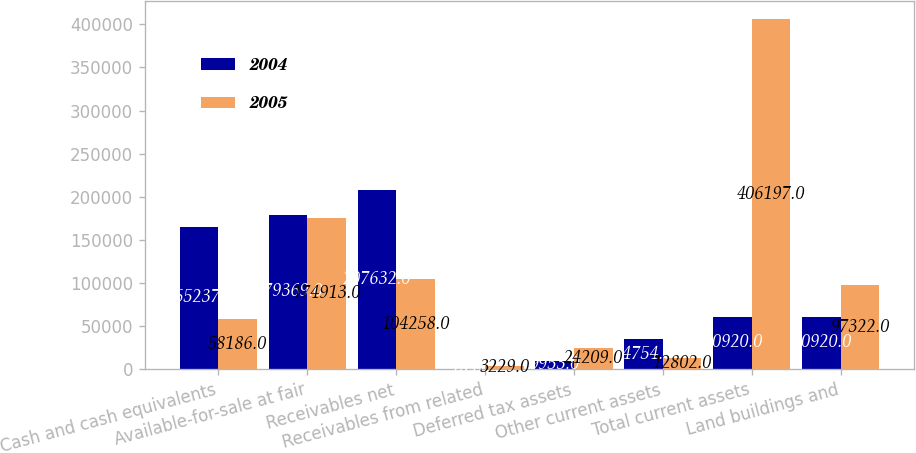Convert chart to OTSL. <chart><loc_0><loc_0><loc_500><loc_500><stacked_bar_chart><ecel><fcel>Cash and cash equivalents<fcel>Available-for-sale at fair<fcel>Receivables net<fcel>Receivables from related<fcel>Deferred tax assets<fcel>Other current assets<fcel>Total current assets<fcel>Land buildings and<nl><fcel>2004<fcel>165237<fcel>179369<fcel>207632<fcel>18<fcel>9953<fcel>34754<fcel>60920<fcel>60920<nl><fcel>2005<fcel>58186<fcel>174913<fcel>104258<fcel>3229<fcel>24209<fcel>12802<fcel>406197<fcel>97322<nl></chart> 